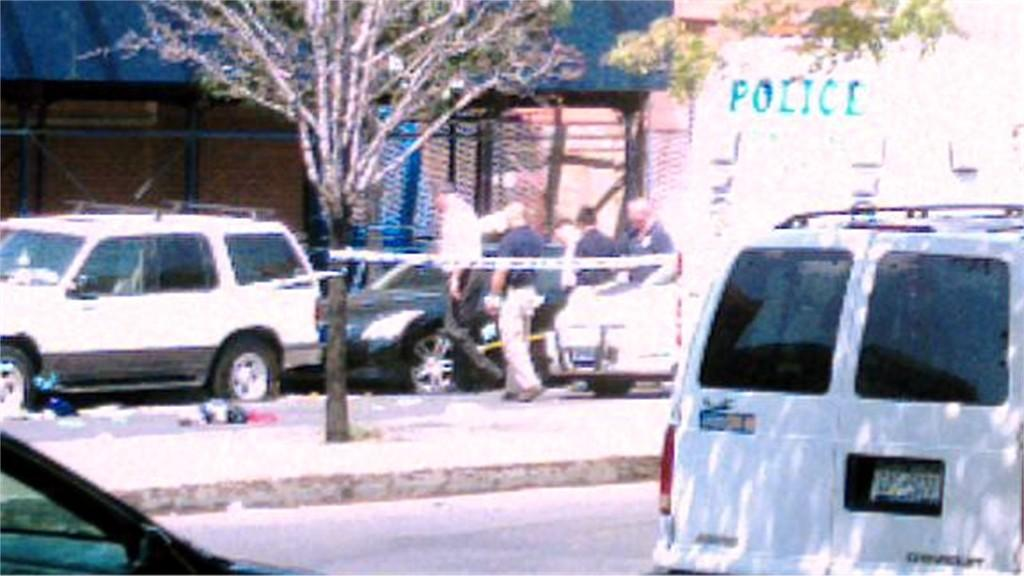Provide a one-sentence caption for the provided image. A white police van is parked on a street and some men are walking around. 